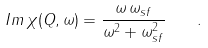<formula> <loc_0><loc_0><loc_500><loc_500>I m \, \chi ( { Q } , \omega ) = \frac { \omega \, \omega _ { s f } } { \omega ^ { 2 } + \omega _ { s f } ^ { 2 } } \quad .</formula> 